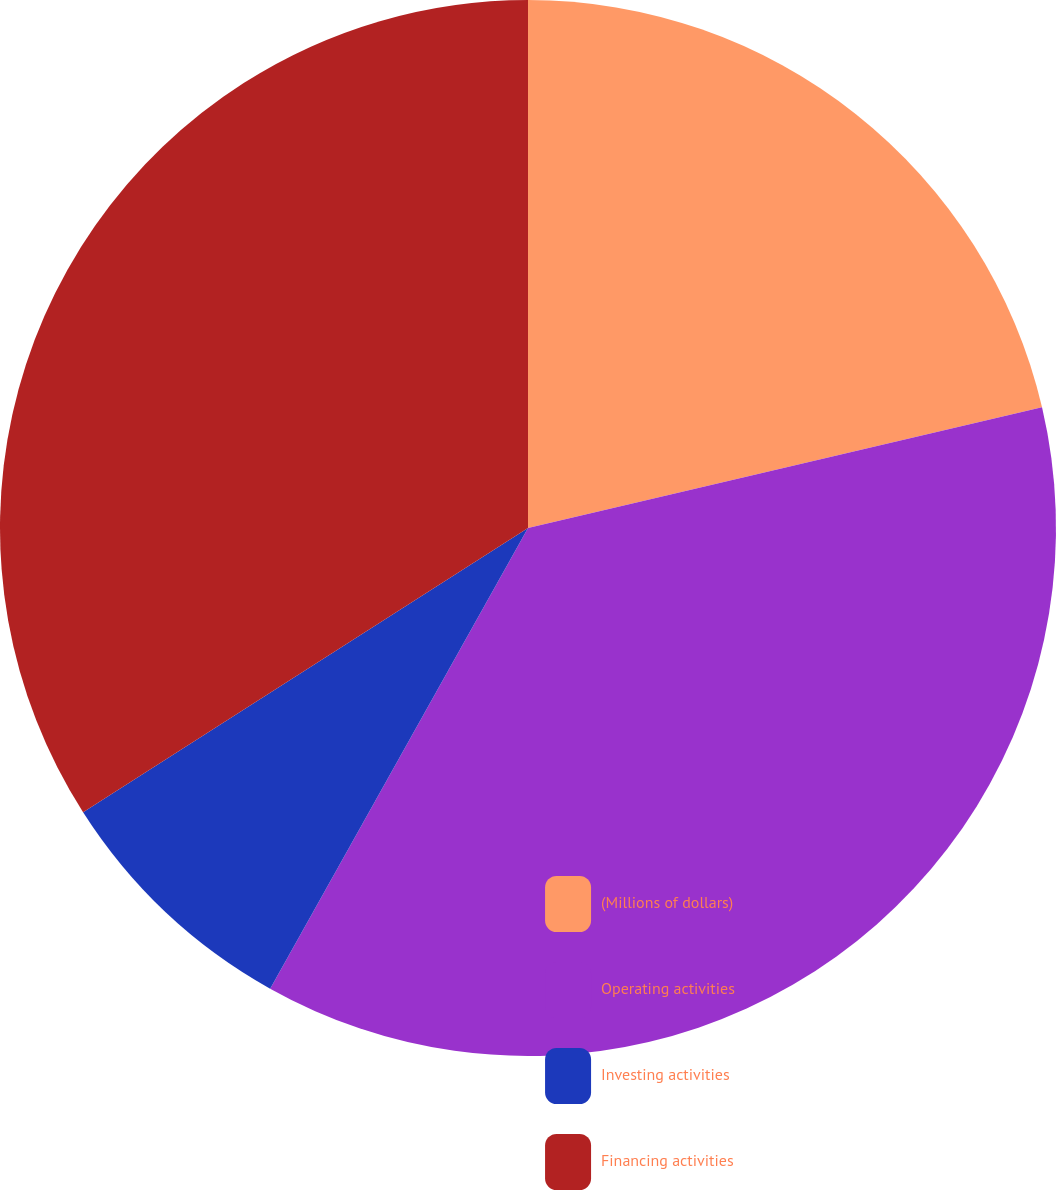Convert chart. <chart><loc_0><loc_0><loc_500><loc_500><pie_chart><fcel>(Millions of dollars)<fcel>Operating activities<fcel>Investing activities<fcel>Financing activities<nl><fcel>21.33%<fcel>36.79%<fcel>7.83%<fcel>34.05%<nl></chart> 